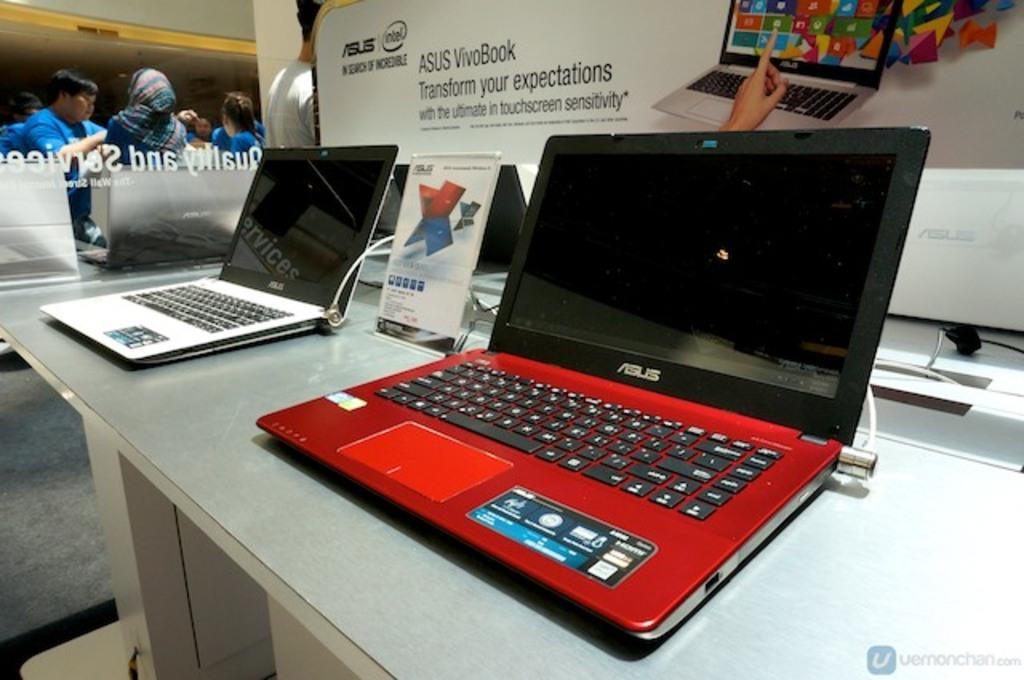<image>
Present a compact description of the photo's key features. A store display of red and white Asus computers. 